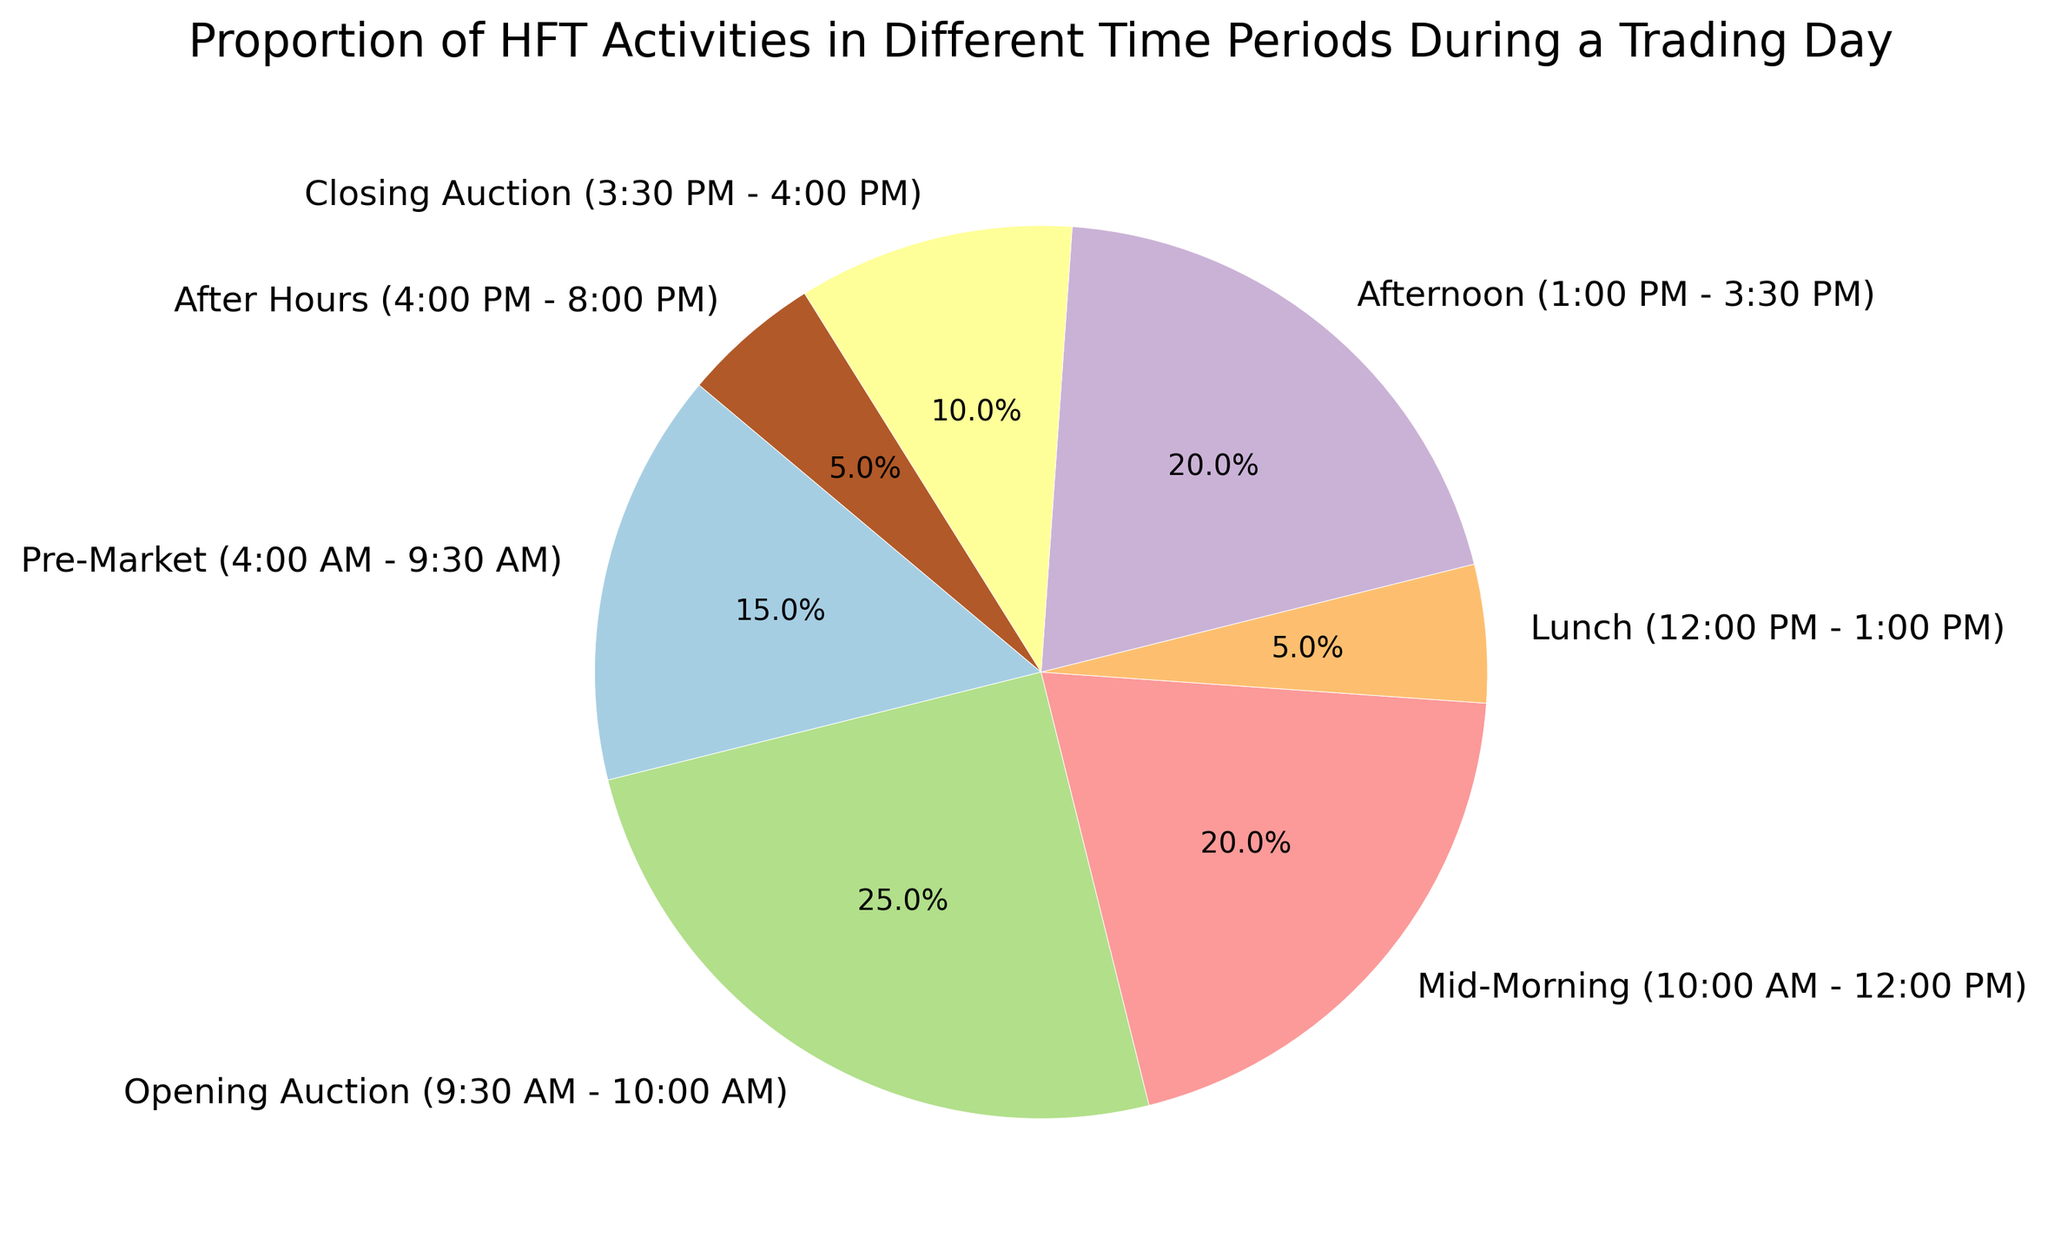Which time period accounts for the largest proportion of HFT activities? By observing the pie chart, we can see which segment has the largest slice. The largest segment is labeled "Opening Auction (9:30 AM - 10:00 AM)" at 25%.
Answer: Opening Auction (9:30 AM - 10:00 AM) What is the combined proportion of HFT activities during the Pre-Market and After Hours periods? We need to add the proportions of Pre-Market (15%) and After Hours (5%). So, 15% + 5% = 20%.
Answer: 20% How does the proportion of HFT activities in the Mid-Morning period compare with the Afternoon period? From the chart, we see that both the Mid-Morning and Afternoon periods are labeled with 20%. Hence, they have equal proportions.
Answer: Equal What is the difference in the proportion of HFT activities between the Opening Auction and Closing Auction periods? The Opening Auction period has a proportion of 25%, and the Closing Auction period has 10%. The difference is 25% - 10% = 15%.
Answer: 15% Which time period has the least proportion of HFT activities and what is that proportion? By looking at the pie chart, the smallest slice is labeled "Lunch (12:00 PM - 1:00 PM)" with a proportion of 5%.
Answer: Lunch (12:00 PM - 1:00 PM) What combined proportion of HFT activities occurs during the main trading hours (from 9:30 AM to 4:00 PM, excluding Lunch)? Sum the proportions of Opening Auction (25%), Mid-Morning (20%), Afternoon (20%), and Closing Auction (10%). 25% + 20% + 20% + 10% = 75%.
Answer: 75% How does the proportion of HFT activities during Lunch compare with that in the After Hours period? Both the Lunch and After Hours periods have proportions of 5%, so they are equal.
Answer: Equal What is the average proportion of HFT activities in the periods with the highest and the lowest activities? The highest proportion is from the Opening Auction (25%), and the lowest is from both Lunch (5%) and After Hours (5%). The average is calculated as (25% + 5%) / 2, so (25 + 5) / 2 = 15%.
Answer: 15% 